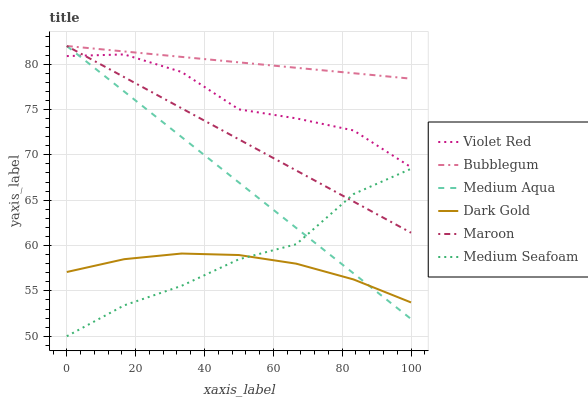Does Dark Gold have the minimum area under the curve?
Answer yes or no. Yes. Does Bubblegum have the maximum area under the curve?
Answer yes or no. Yes. Does Maroon have the minimum area under the curve?
Answer yes or no. No. Does Maroon have the maximum area under the curve?
Answer yes or no. No. Is Medium Aqua the smoothest?
Answer yes or no. Yes. Is Violet Red the roughest?
Answer yes or no. Yes. Is Dark Gold the smoothest?
Answer yes or no. No. Is Dark Gold the roughest?
Answer yes or no. No. Does Dark Gold have the lowest value?
Answer yes or no. No. Does Bubblegum have the highest value?
Answer yes or no. Yes. Does Dark Gold have the highest value?
Answer yes or no. No. Is Dark Gold less than Bubblegum?
Answer yes or no. Yes. Is Violet Red greater than Dark Gold?
Answer yes or no. Yes. Does Medium Seafoam intersect Dark Gold?
Answer yes or no. Yes. Is Medium Seafoam less than Dark Gold?
Answer yes or no. No. Is Medium Seafoam greater than Dark Gold?
Answer yes or no. No. Does Dark Gold intersect Bubblegum?
Answer yes or no. No. 